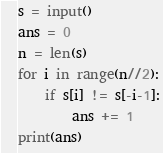Convert code to text. <code><loc_0><loc_0><loc_500><loc_500><_Python_>s = input()
ans = 0
n = len(s)
for i in range(n//2):
    if s[i] != s[-i-1]:
        ans += 1
print(ans)</code> 